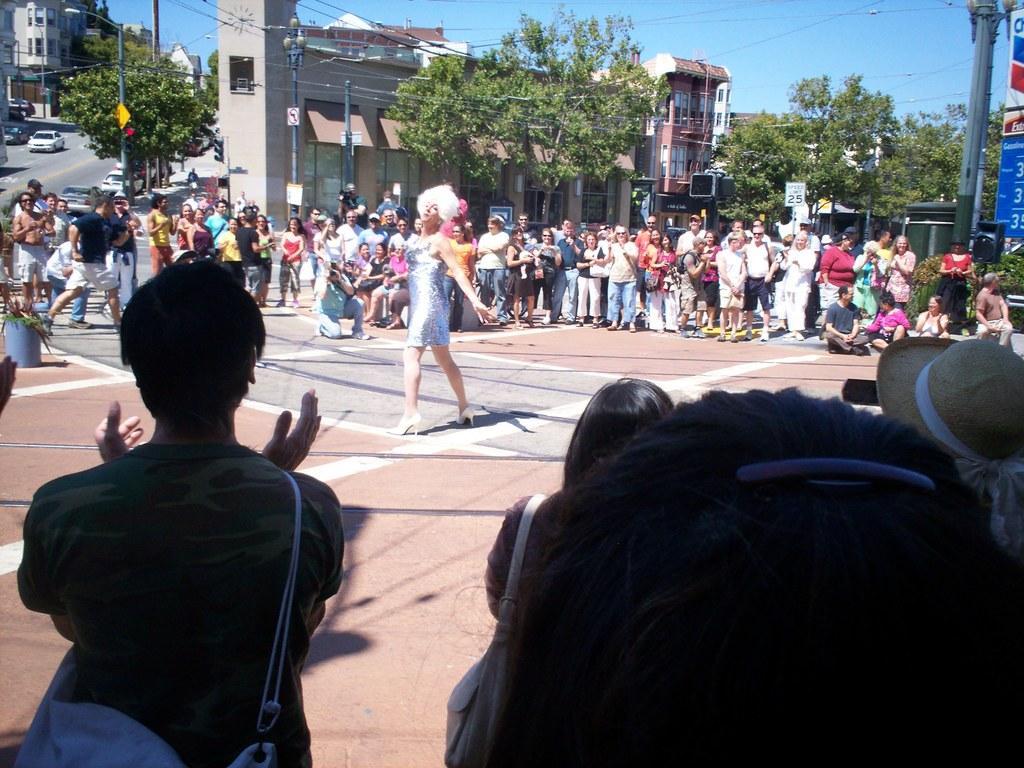How would you summarize this image in a sentence or two? In this picture there are people, among them there is woman dancing and we can see plants, poles, boards, wires, banner and lights. We can see buildings, trees and vehicles. In the background of the image we can see the sky. 